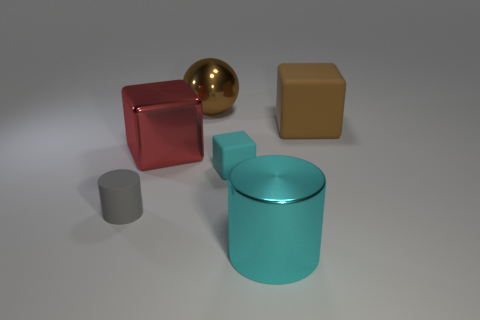There is a sphere; is it the same color as the large matte cube right of the small rubber cylinder?
Your answer should be very brief. Yes. What number of big cubes are on the right side of the large shiny object that is right of the small cyan cube?
Your answer should be compact. 1. What color is the shiny object behind the large block right of the large metal cylinder?
Keep it short and to the point. Brown. There is a object that is both on the right side of the brown metallic object and behind the red block; what material is it?
Your answer should be very brief. Rubber. Are there any other large cyan objects of the same shape as the large cyan object?
Make the answer very short. No. Do the small object that is to the right of the large red cube and the red thing have the same shape?
Make the answer very short. Yes. How many matte things are both left of the brown matte cube and on the right side of the small matte cylinder?
Give a very brief answer. 1. There is a cyan thing that is in front of the tiny cylinder; what shape is it?
Keep it short and to the point. Cylinder. How many big brown blocks have the same material as the small cyan object?
Make the answer very short. 1. There is a large red object; is its shape the same as the large metallic thing behind the red block?
Provide a succinct answer. No. 